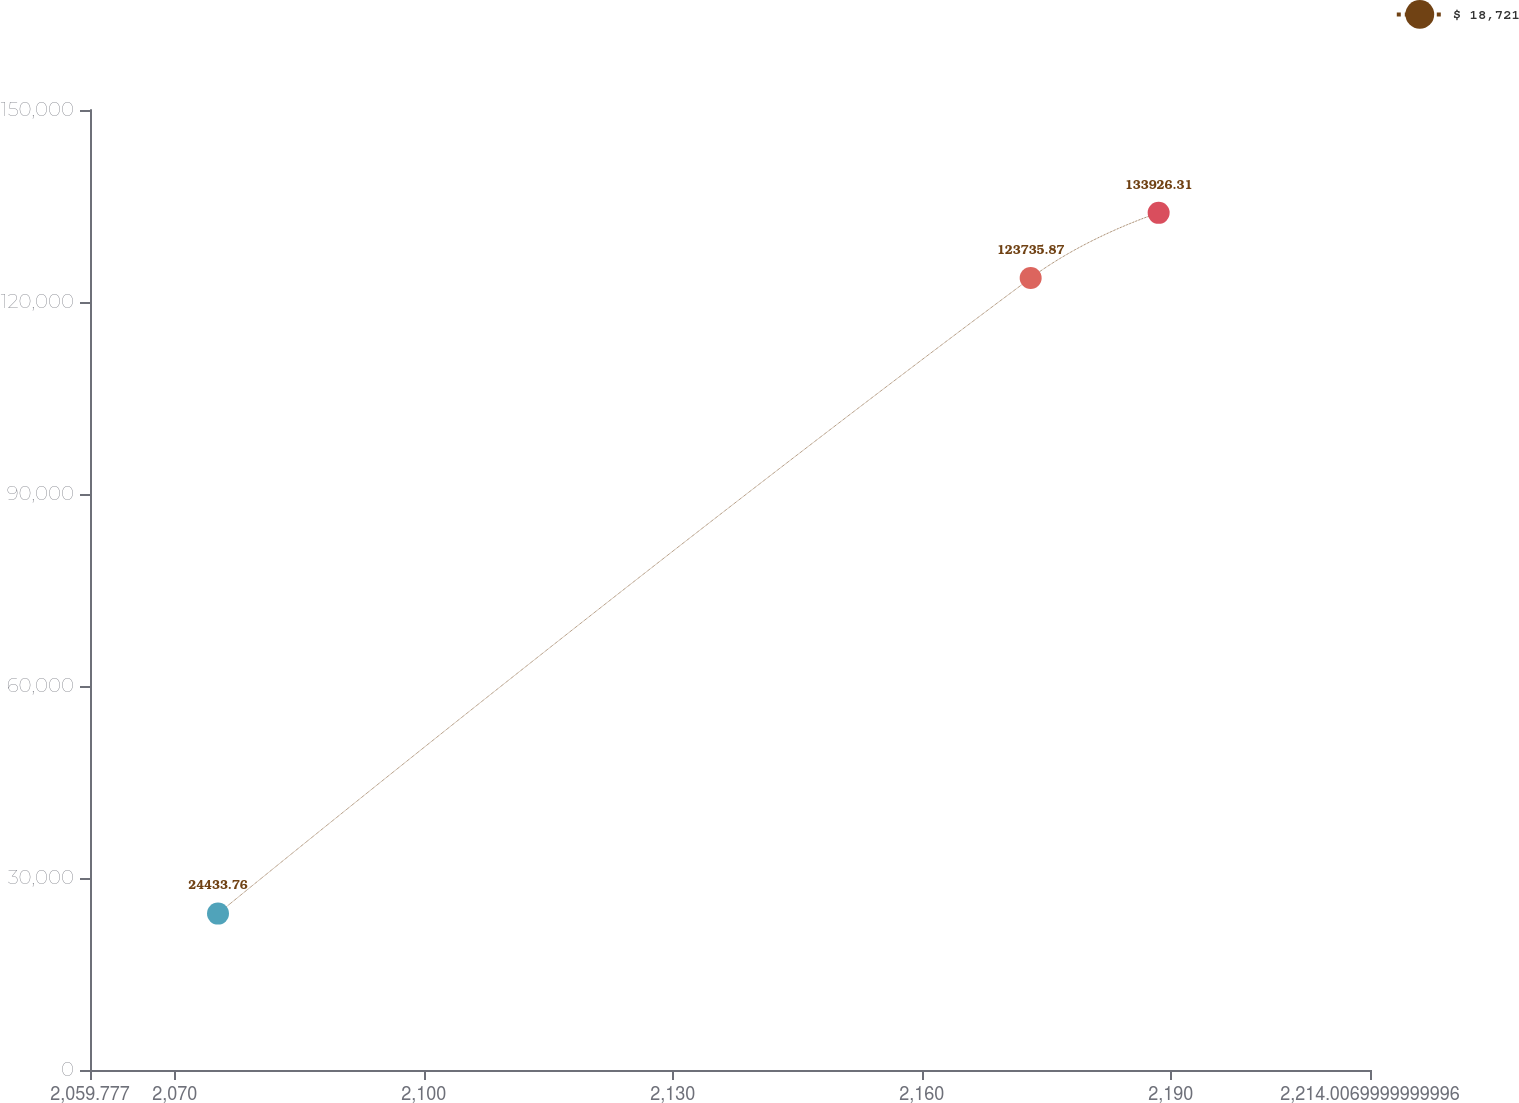Convert chart. <chart><loc_0><loc_0><loc_500><loc_500><line_chart><ecel><fcel>$ 18,721<nl><fcel>2075.2<fcel>24433.8<nl><fcel>2173.12<fcel>123736<nl><fcel>2188.54<fcel>133926<nl><fcel>2229.43<fcel>54995.3<nl></chart> 